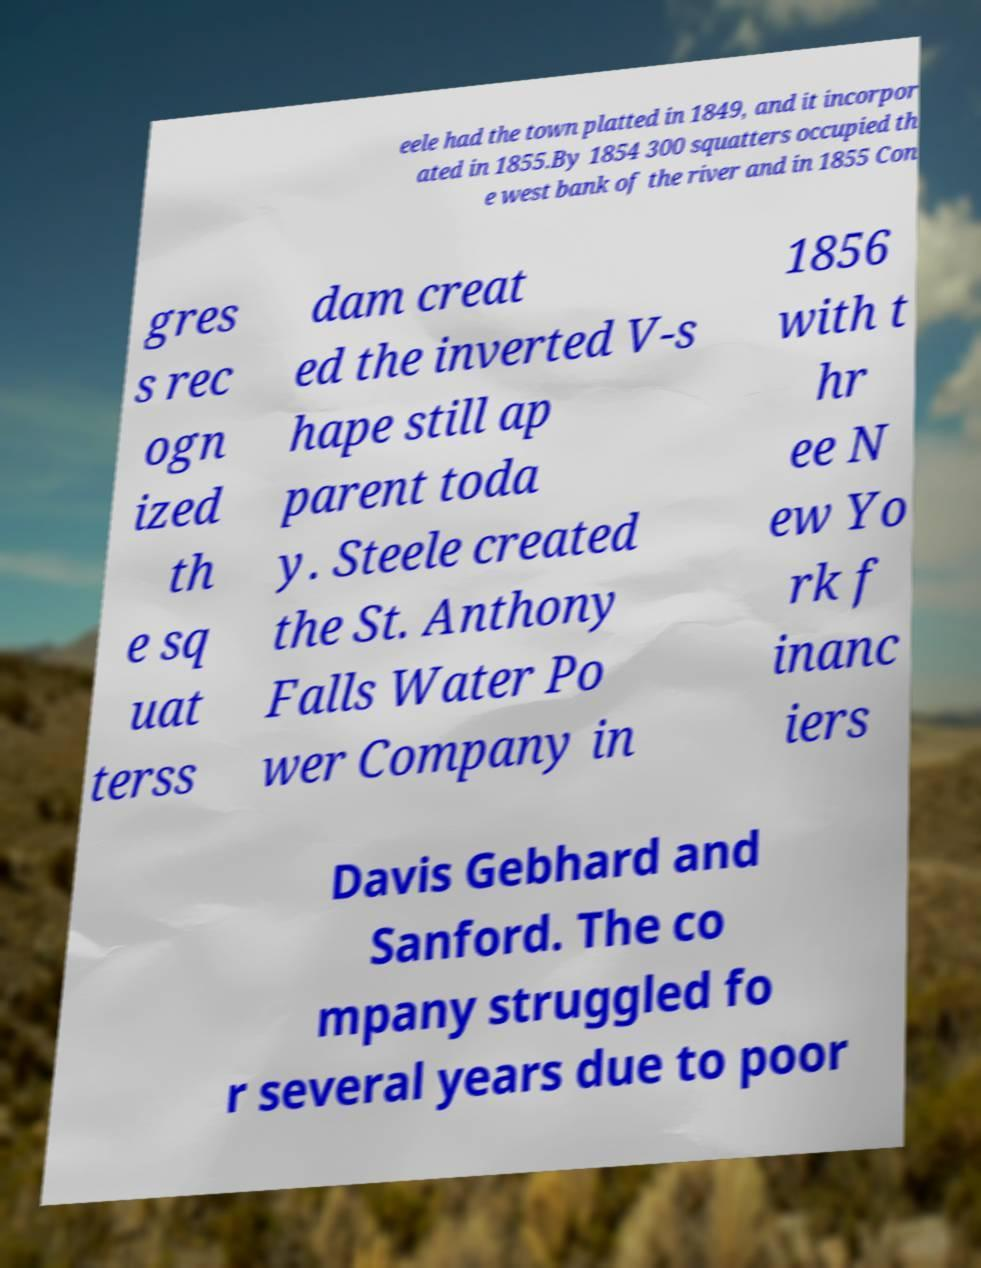Could you assist in decoding the text presented in this image and type it out clearly? eele had the town platted in 1849, and it incorpor ated in 1855.By 1854 300 squatters occupied th e west bank of the river and in 1855 Con gres s rec ogn ized th e sq uat terss dam creat ed the inverted V-s hape still ap parent toda y. Steele created the St. Anthony Falls Water Po wer Company in 1856 with t hr ee N ew Yo rk f inanc iers Davis Gebhard and Sanford. The co mpany struggled fo r several years due to poor 